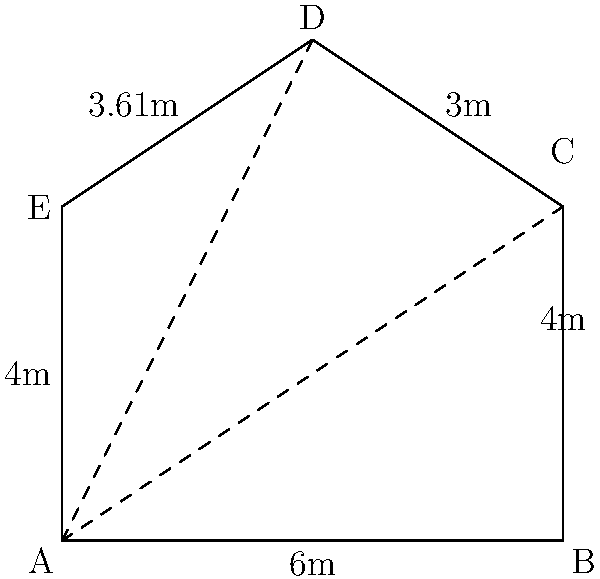In a murder investigation, the crime scene is an irregular pentagon-shaped room. The forensic team has measured the sides and some diagonals of the room as follows: AB = 6m, BC = 4m, CD = 3m, DE ≈ 3.61m, and EA = 4m. Diagonals AC and AD measure 7.21m and 6.71m respectively. Calculate the area of the crime scene to the nearest square meter. To find the area of the irregular pentagon, we can divide it into three triangles: ABC, ACD, and ADE. We'll calculate the area of each triangle and sum them up.

1. Triangle ABC:
   We know AB = 6m and BC = 4m. Using the Pythagorean theorem with AC = 7.21m:
   $AC^2 = AB^2 + BC^2$
   $7.21^2 = 6^2 + 4^2$
   $52.0041 = 36 + 16 = 52$ (confirms our measurements)
   Area of ABC = $\frac{1}{2} \times 6 \times 4 = 12$ m²

2. Triangle ACD:
   We know AC = 7.21m, CD = 3m, and AD = 6.71m. Using Heron's formula:
   $s = \frac{7.21 + 3 + 6.71}{2} = 8.46$
   Area of ACD = $\sqrt{s(s-a)(s-b)(s-c)}$
                = $\sqrt{8.46(8.46-7.21)(8.46-3)(8.46-6.71)}$
                ≈ 9.03 m²

3. Triangle ADE:
   We know AD = 6.71m, DE = 3.61m, and AE = 4m. Using Heron's formula again:
   $s = \frac{6.71 + 3.61 + 4}{2} = 7.16$
   Area of ADE = $\sqrt{s(s-a)(s-b)(s-c)}$
                = $\sqrt{7.16(7.16-6.71)(7.16-3.61)(7.16-4)}$
                ≈ 6.97 m²

4. Total area:
   Area of pentagon = Area of ABC + Area of ACD + Area of ADE
                    = 12 + 9.03 + 6.97
                    = 28 m² (rounded to the nearest square meter)
Answer: 28 m² 